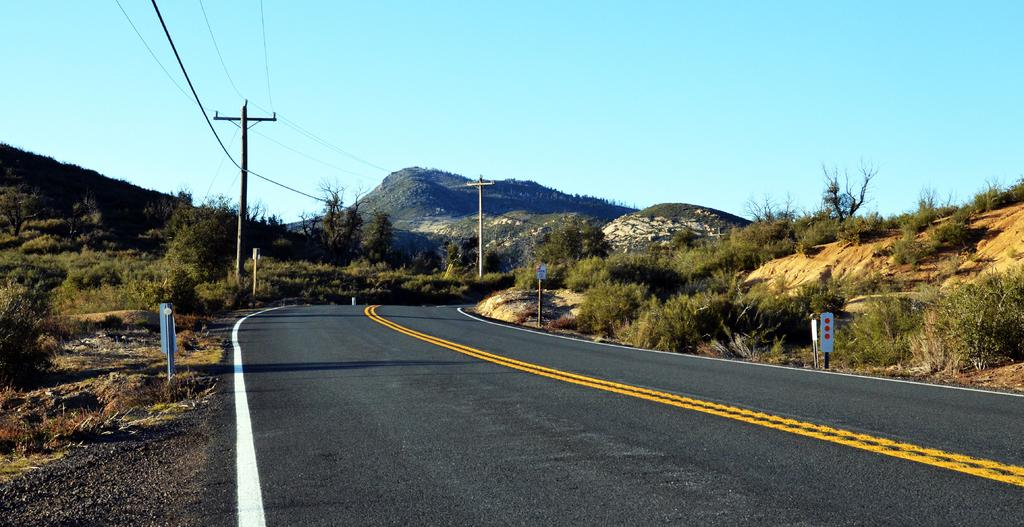What type of road is shown in the image? The image depicts a one-way road. What structures can be seen alongside the road? There are poles and wires visible in the image. What type of vegetation is present in the image? Plants are visible in the image. What can be seen in the distance in the image? There is a hill in the background of the image, and the sky is visible as well. What type of plate is used to serve lunch in the image? There is no plate or lunch being served in the image; it depicts a one-way road with poles, wires, plants, a hill, and the sky. 